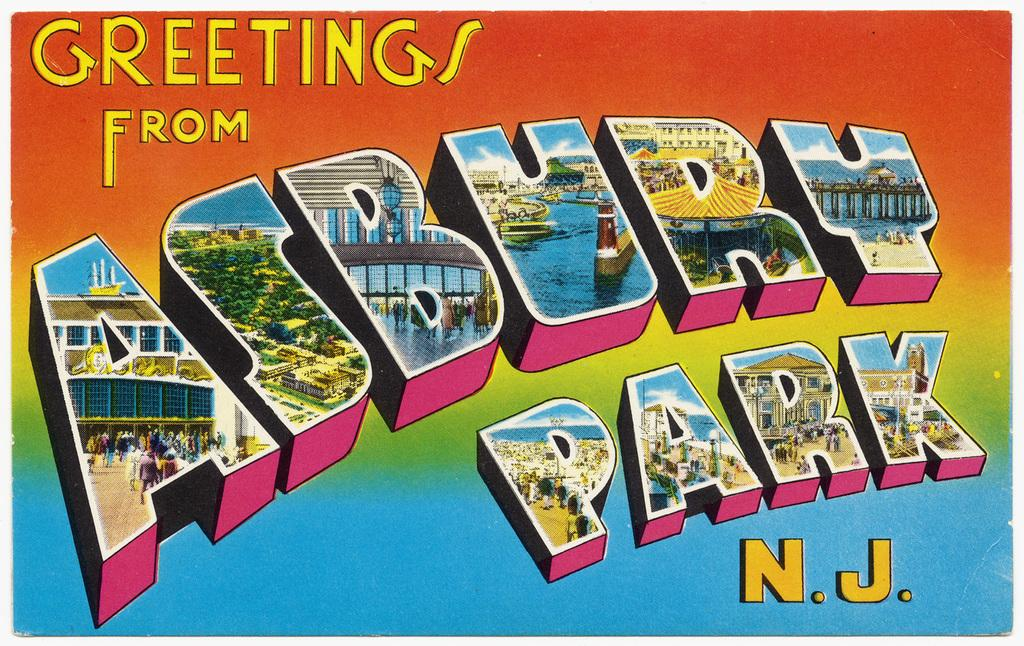<image>
Create a compact narrative representing the image presented. A colorful postcard that says greetings from Asbury Park, NJ. 